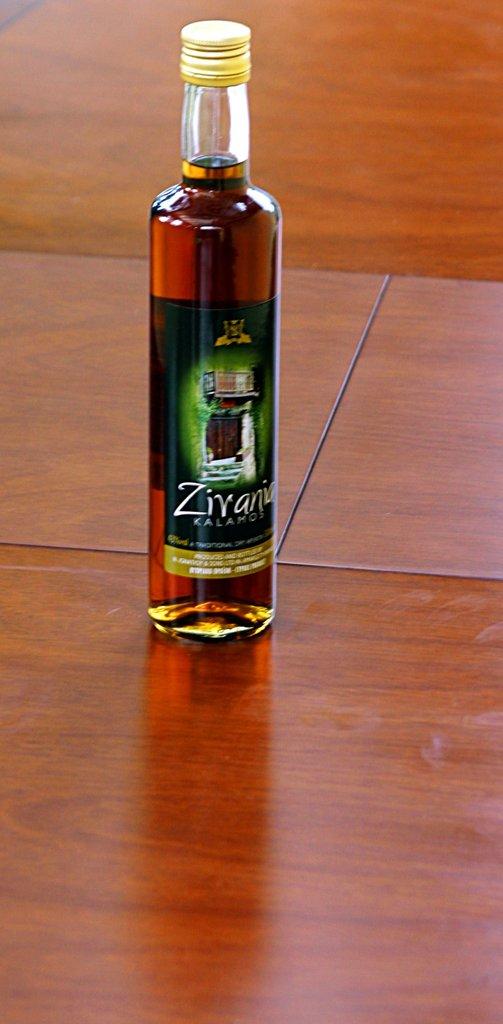What is the name of this item?
Make the answer very short. Zirania. What are the letter colors?
Ensure brevity in your answer.  White. 